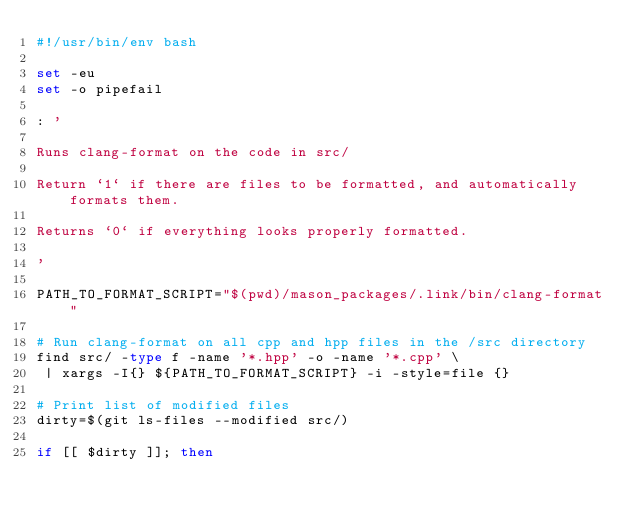<code> <loc_0><loc_0><loc_500><loc_500><_Bash_>#!/usr/bin/env bash

set -eu
set -o pipefail

: '

Runs clang-format on the code in src/

Return `1` if there are files to be formatted, and automatically formats them.

Returns `0` if everything looks properly formatted.

'

PATH_TO_FORMAT_SCRIPT="$(pwd)/mason_packages/.link/bin/clang-format"

# Run clang-format on all cpp and hpp files in the /src directory
find src/ -type f -name '*.hpp' -o -name '*.cpp' \
 | xargs -I{} ${PATH_TO_FORMAT_SCRIPT} -i -style=file {}

# Print list of modified files
dirty=$(git ls-files --modified src/)

if [[ $dirty ]]; then</code> 